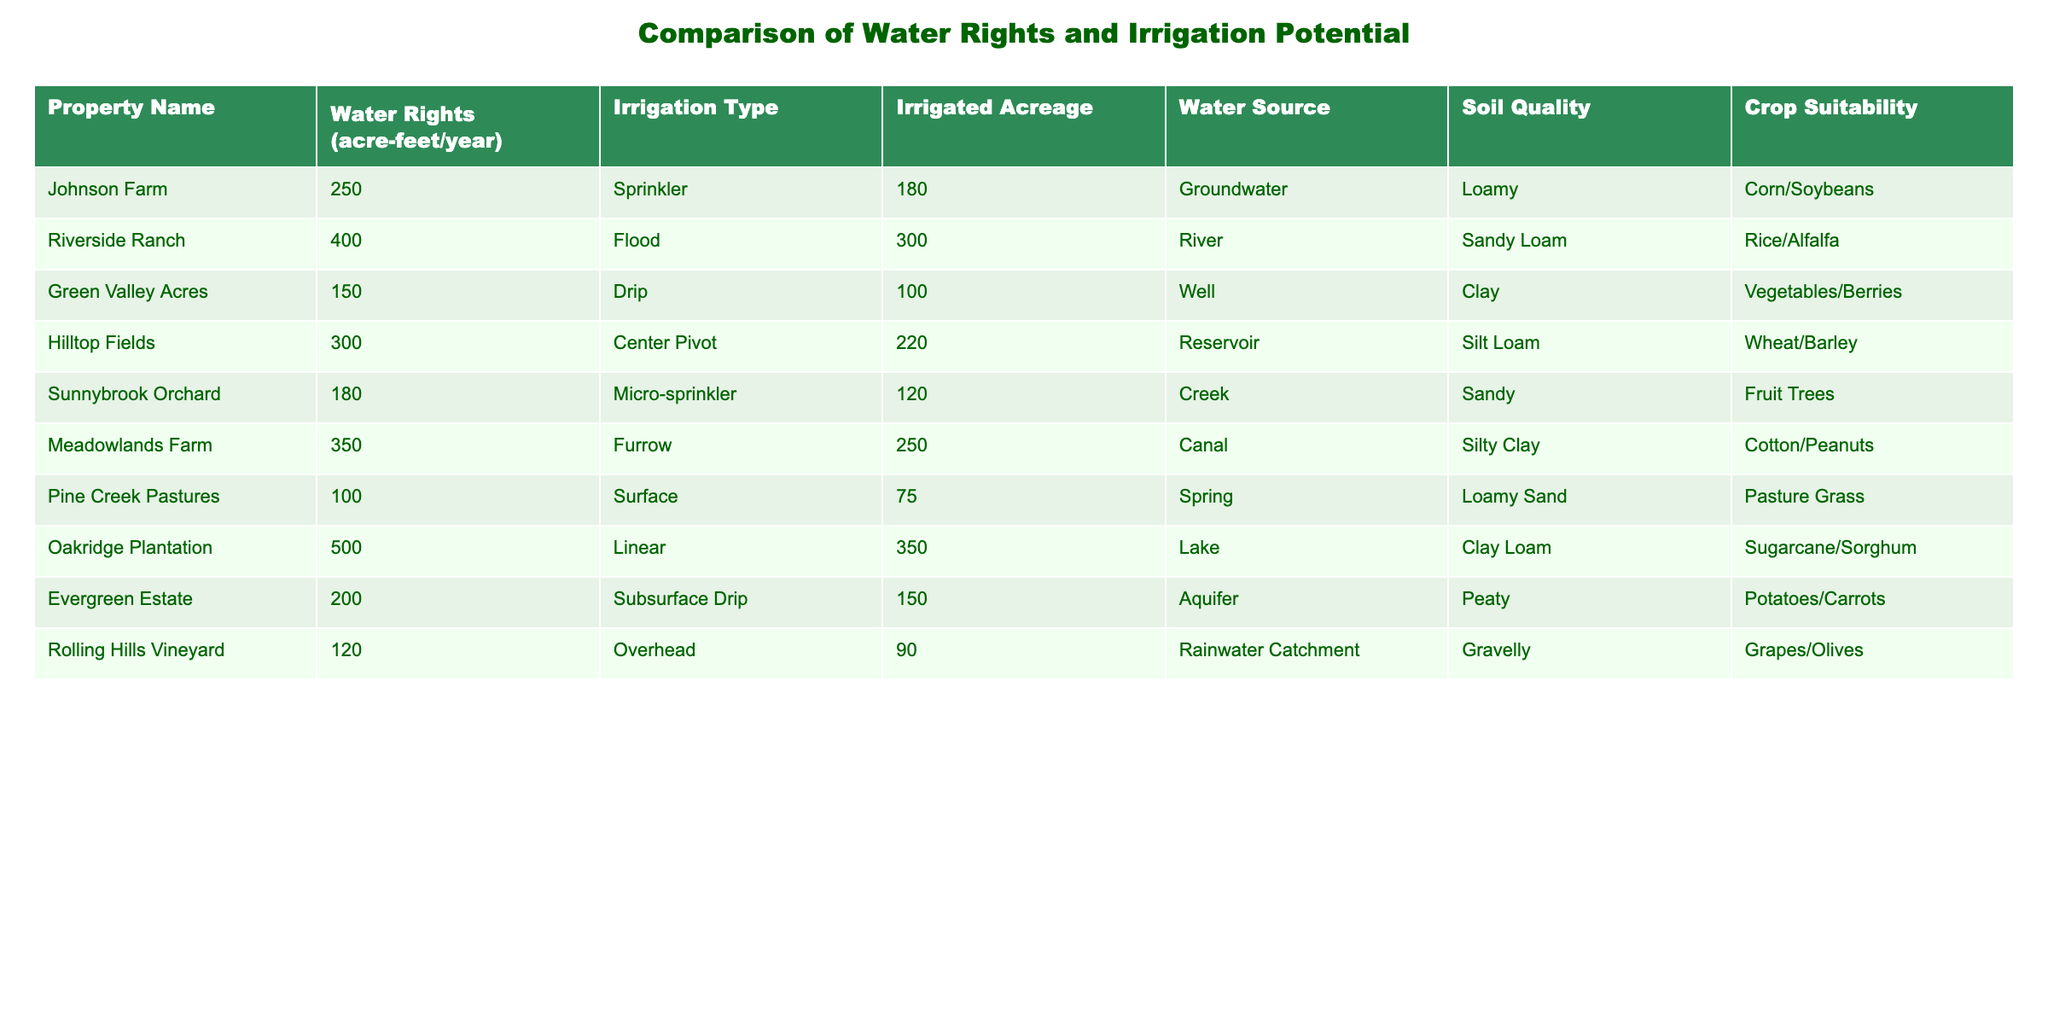What is the property with the highest water rights? By scanning the column labeled "Water Rights," I find that the maximum value is 500 acre-feet/year, which corresponds to Oakridge Plantation.
Answer: Oakridge Plantation How many acres can Oakridge Plantation irrigate? In the table, the row for Oakridge Plantation shows it has 350 irrigated acres, which is a specific value listed in the "Irrigated Acreage" column.
Answer: 350 What is the average irrigated acreage of all properties? To calculate the average, I add the irrigated acreages (180 + 300 + 100 + 220 + 120 + 250 + 75 + 350 + 150 + 90 = 1885) and divide by the number of properties (10). Thus, the average is 1885 / 10 = 188.5 acres.
Answer: 188.5 Is there a property that uses groundwater as its water source? By checking the "Water Source" column, I see that Johnson Farm is listed as using groundwater. Therefore, the answer is yes.
Answer: Yes Which property has the highest irrigation potential based on soil quality? I assess the "Soil Quality" and check the associated crop suitability for each property. While there is no direct metric for irrigation potential based on soil quality, Oakridge Plantation with Clay Loam and Johnson Farm with Loamy soil quality are highly suitable for their respective crops. A deeper analysis considering crop suitability indicates Oakridge Plantation might have higher irrigation potential.
Answer: Oakridge Plantation 